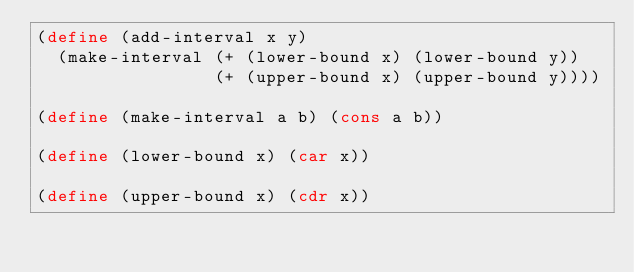<code> <loc_0><loc_0><loc_500><loc_500><_Scheme_>(define (add-interval x y)
  (make-interval (+ (lower-bound x) (lower-bound y))
                 (+ (upper-bound x) (upper-bound y))))

(define (make-interval a b) (cons a b))

(define (lower-bound x) (car x))

(define (upper-bound x) (cdr x))
</code> 